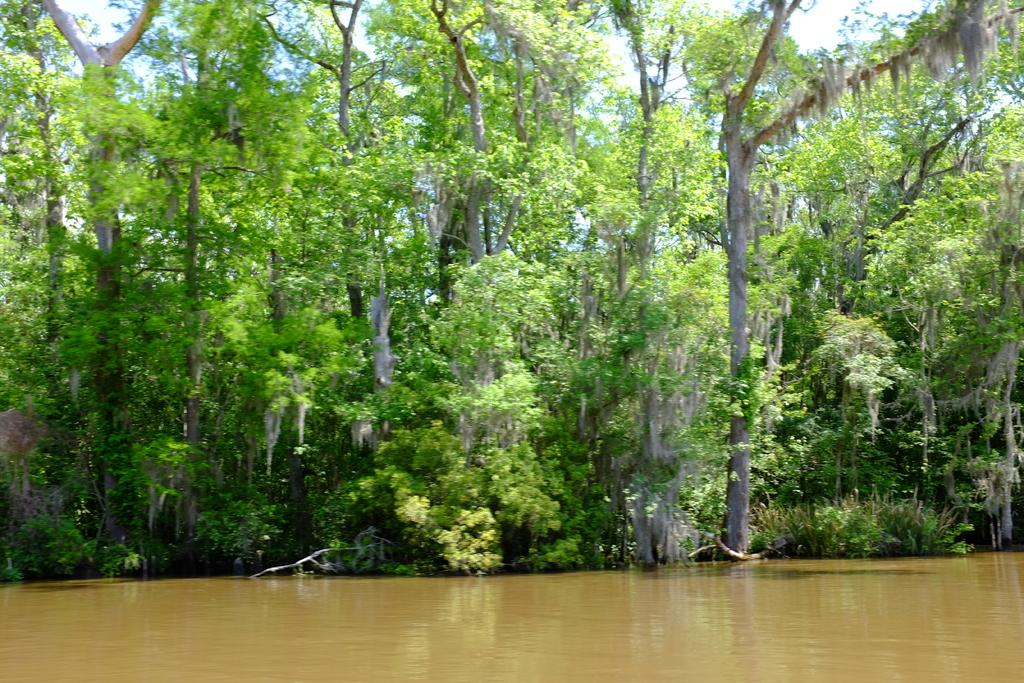What type of vegetation can be seen in the image? There are plants and trees in the image. What part of the natural environment is visible in the image? The sky is visible in the image. What body of water is present in the image? There is a river in the image. What type of plot does the cat use to trick the birds in the image? There is no cat or plot present in the image; it features plants, trees, the sky, and a river. 